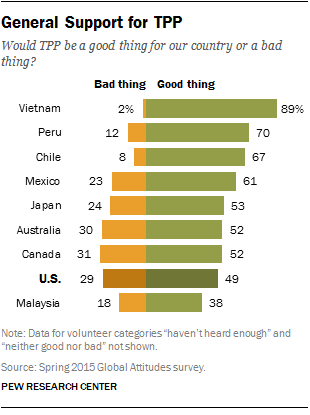Outline some significant characteristics in this image. Vietnam is the country that most strongly supports the Trans-Pacific Partnership (TPP). Seventy percent or more of the countries support this issue. 